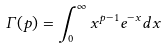<formula> <loc_0><loc_0><loc_500><loc_500>\Gamma ( p ) = \int \nolimits _ { 0 } ^ { \infty } x ^ { p - 1 } e ^ { - x } d x</formula> 